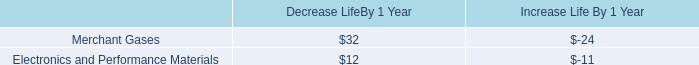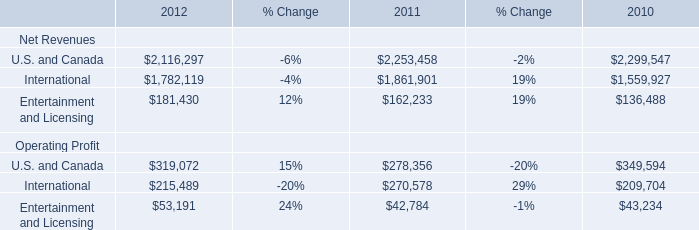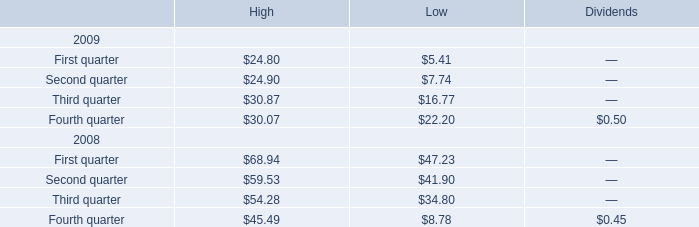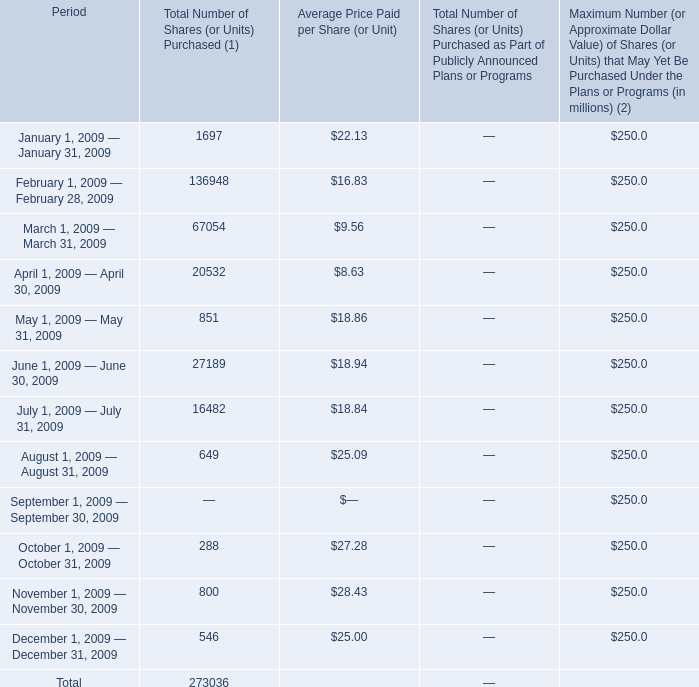When does Total Number of Shares reach the largest value? 
Answer: February 1, 2009 — February 28, 2009. 